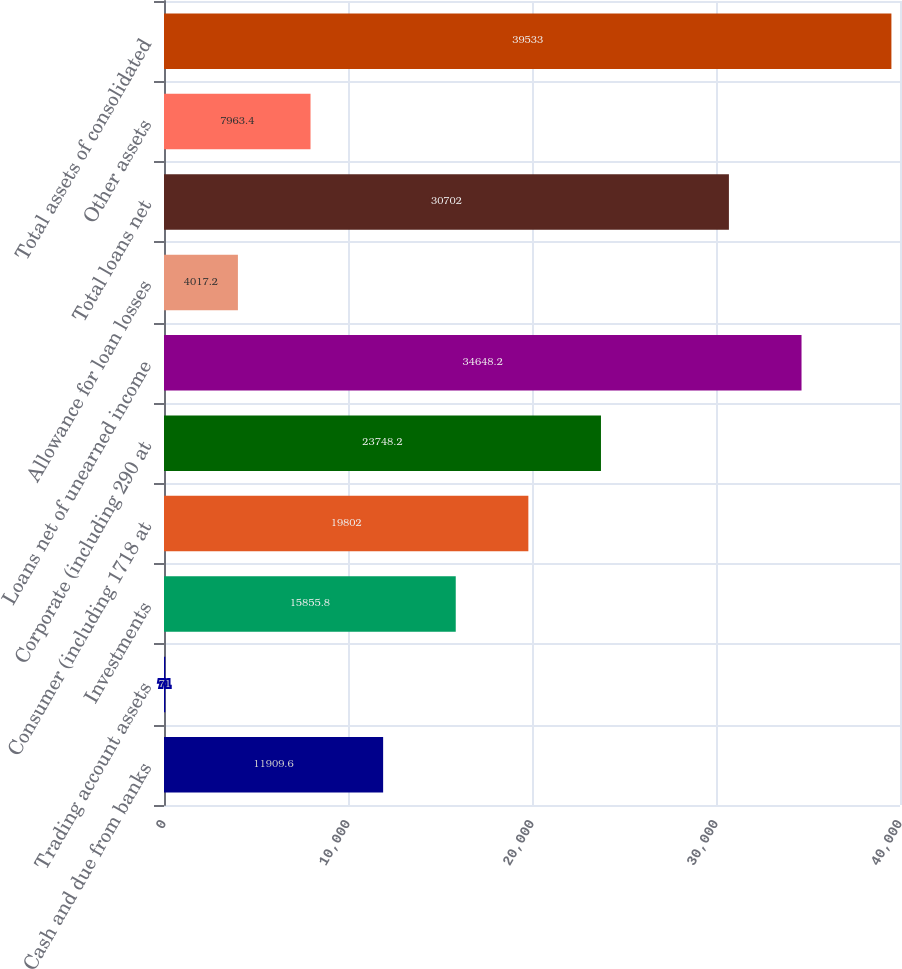Convert chart. <chart><loc_0><loc_0><loc_500><loc_500><bar_chart><fcel>Cash and due from banks<fcel>Trading account assets<fcel>Investments<fcel>Consumer (including 1718 at<fcel>Corporate (including 290 at<fcel>Loans net of unearned income<fcel>Allowance for loan losses<fcel>Total loans net<fcel>Other assets<fcel>Total assets of consolidated<nl><fcel>11909.6<fcel>71<fcel>15855.8<fcel>19802<fcel>23748.2<fcel>34648.2<fcel>4017.2<fcel>30702<fcel>7963.4<fcel>39533<nl></chart> 